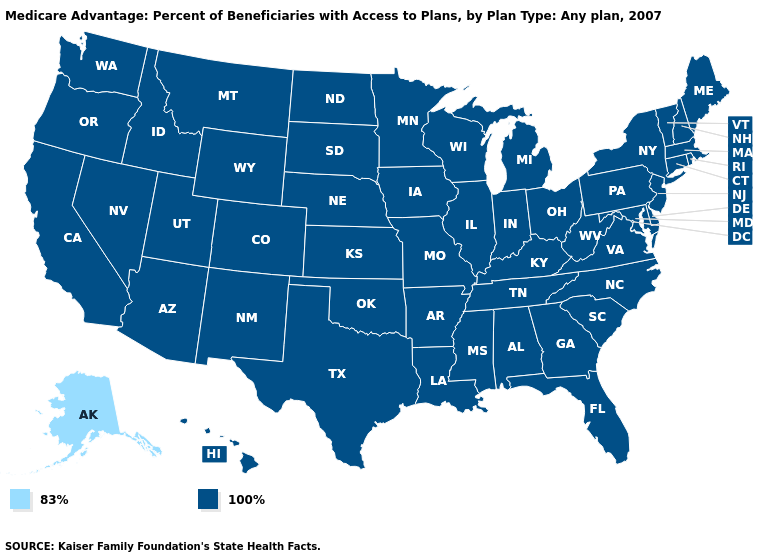Does the map have missing data?
Be succinct. No. Which states have the highest value in the USA?
Keep it brief. Alabama, Arkansas, Arizona, California, Colorado, Connecticut, Delaware, Florida, Georgia, Hawaii, Iowa, Idaho, Illinois, Indiana, Kansas, Kentucky, Louisiana, Massachusetts, Maryland, Maine, Michigan, Minnesota, Missouri, Mississippi, Montana, North Carolina, North Dakota, Nebraska, New Hampshire, New Jersey, New Mexico, Nevada, New York, Ohio, Oklahoma, Oregon, Pennsylvania, Rhode Island, South Carolina, South Dakota, Tennessee, Texas, Utah, Virginia, Vermont, Washington, Wisconsin, West Virginia, Wyoming. What is the value of Washington?
Answer briefly. 100%. What is the highest value in states that border Louisiana?
Concise answer only. 100%. What is the value of Delaware?
Keep it brief. 100%. What is the highest value in the USA?
Keep it brief. 100%. Name the states that have a value in the range 83%?
Keep it brief. Alaska. Name the states that have a value in the range 83%?
Answer briefly. Alaska. Name the states that have a value in the range 100%?
Quick response, please. Alabama, Arkansas, Arizona, California, Colorado, Connecticut, Delaware, Florida, Georgia, Hawaii, Iowa, Idaho, Illinois, Indiana, Kansas, Kentucky, Louisiana, Massachusetts, Maryland, Maine, Michigan, Minnesota, Missouri, Mississippi, Montana, North Carolina, North Dakota, Nebraska, New Hampshire, New Jersey, New Mexico, Nevada, New York, Ohio, Oklahoma, Oregon, Pennsylvania, Rhode Island, South Carolina, South Dakota, Tennessee, Texas, Utah, Virginia, Vermont, Washington, Wisconsin, West Virginia, Wyoming. Is the legend a continuous bar?
Quick response, please. No. Does New Hampshire have the same value as Alaska?
Answer briefly. No. Does Alaska have a higher value than South Carolina?
Concise answer only. No. Among the states that border Pennsylvania , which have the highest value?
Answer briefly. Delaware, Maryland, New Jersey, New York, Ohio, West Virginia. What is the value of Nebraska?
Answer briefly. 100%. 